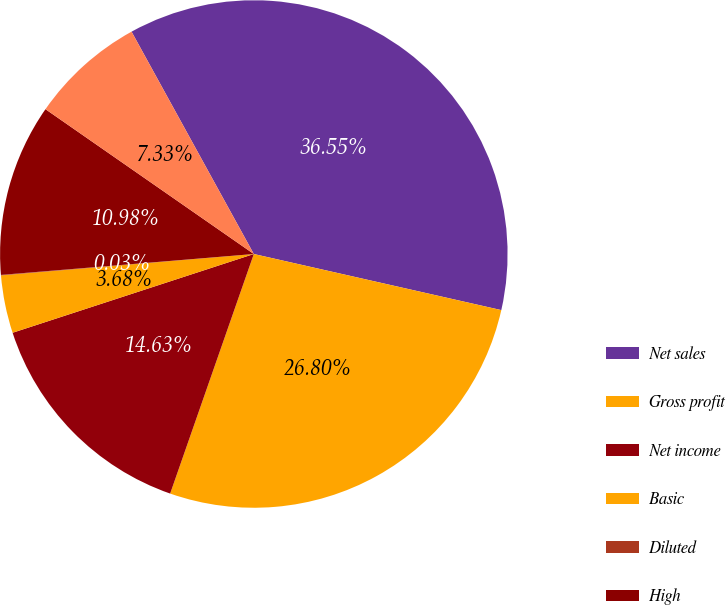Convert chart. <chart><loc_0><loc_0><loc_500><loc_500><pie_chart><fcel>Net sales<fcel>Gross profit<fcel>Net income<fcel>Basic<fcel>Diluted<fcel>High<fcel>Low<nl><fcel>36.55%<fcel>26.8%<fcel>14.63%<fcel>3.68%<fcel>0.03%<fcel>10.98%<fcel>7.33%<nl></chart> 